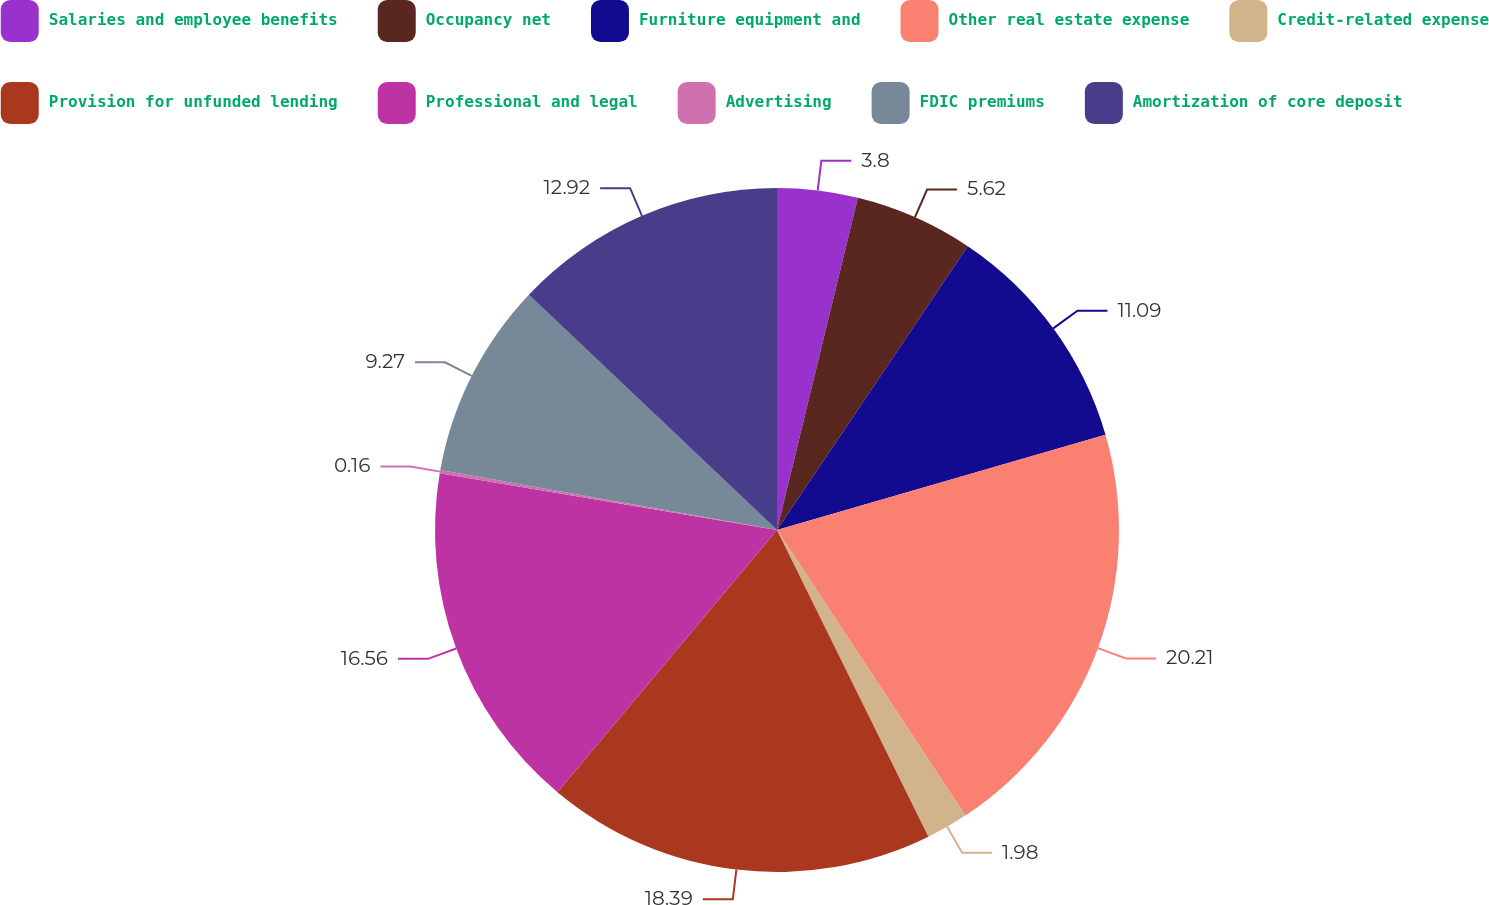Convert chart. <chart><loc_0><loc_0><loc_500><loc_500><pie_chart><fcel>Salaries and employee benefits<fcel>Occupancy net<fcel>Furniture equipment and<fcel>Other real estate expense<fcel>Credit-related expense<fcel>Provision for unfunded lending<fcel>Professional and legal<fcel>Advertising<fcel>FDIC premiums<fcel>Amortization of core deposit<nl><fcel>3.8%<fcel>5.62%<fcel>11.09%<fcel>20.21%<fcel>1.98%<fcel>18.39%<fcel>16.56%<fcel>0.16%<fcel>9.27%<fcel>12.92%<nl></chart> 